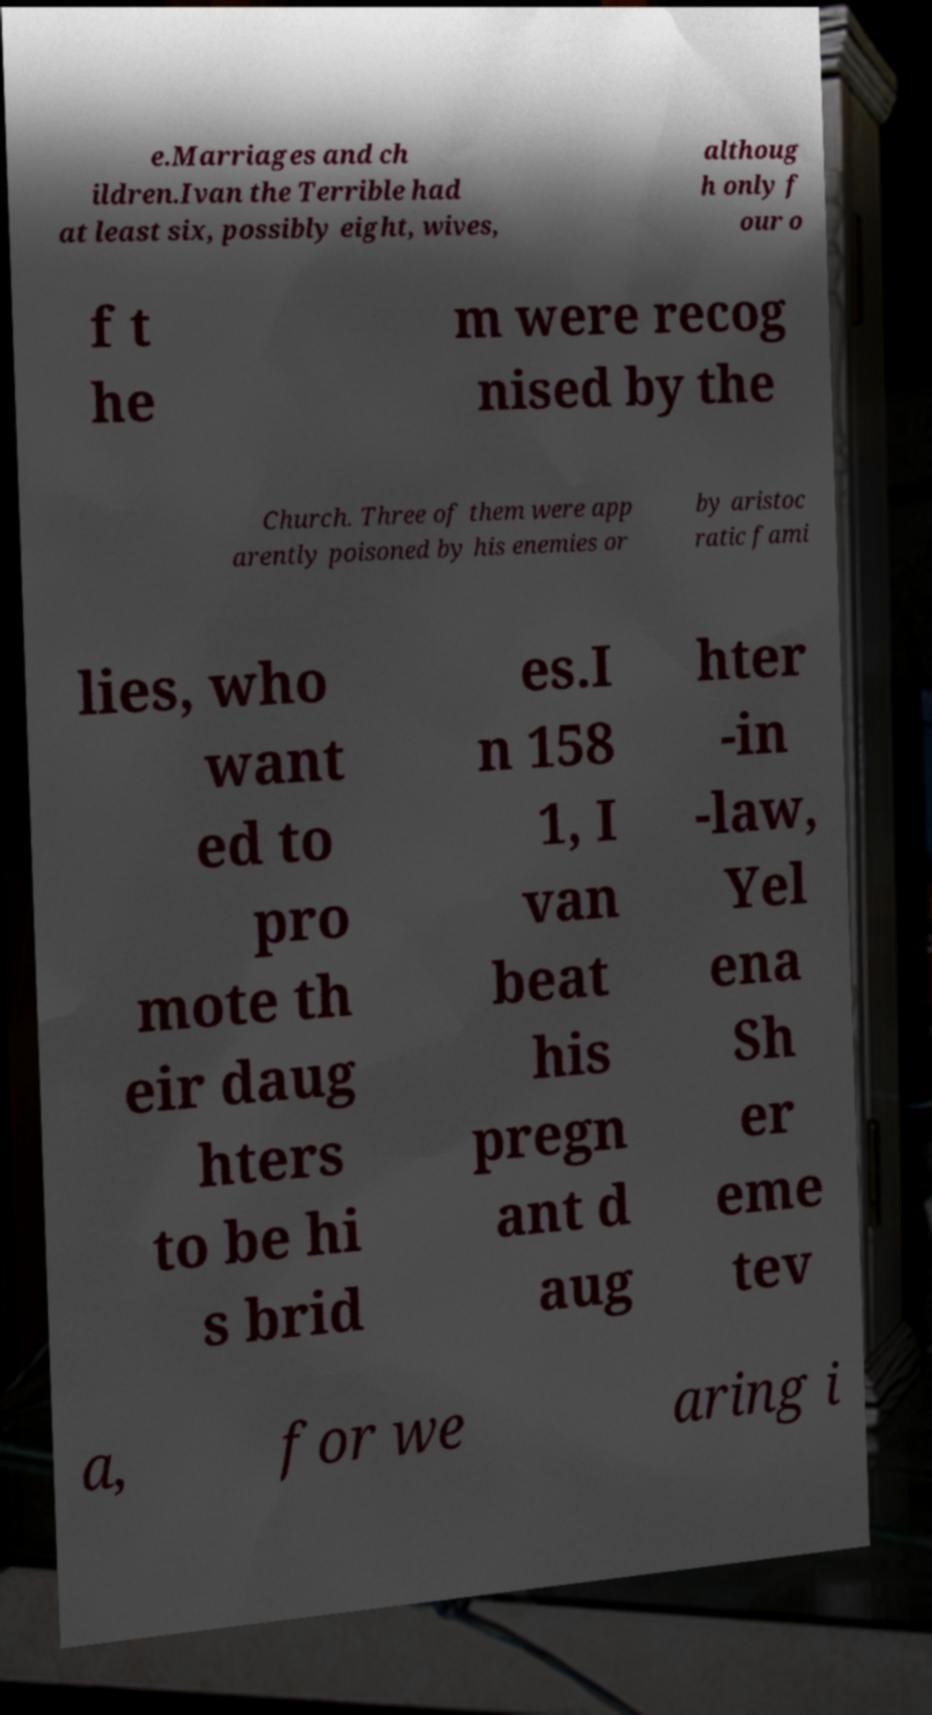For documentation purposes, I need the text within this image transcribed. Could you provide that? e.Marriages and ch ildren.Ivan the Terrible had at least six, possibly eight, wives, althoug h only f our o f t he m were recog nised by the Church. Three of them were app arently poisoned by his enemies or by aristoc ratic fami lies, who want ed to pro mote th eir daug hters to be hi s brid es.I n 158 1, I van beat his pregn ant d aug hter -in -law, Yel ena Sh er eme tev a, for we aring i 